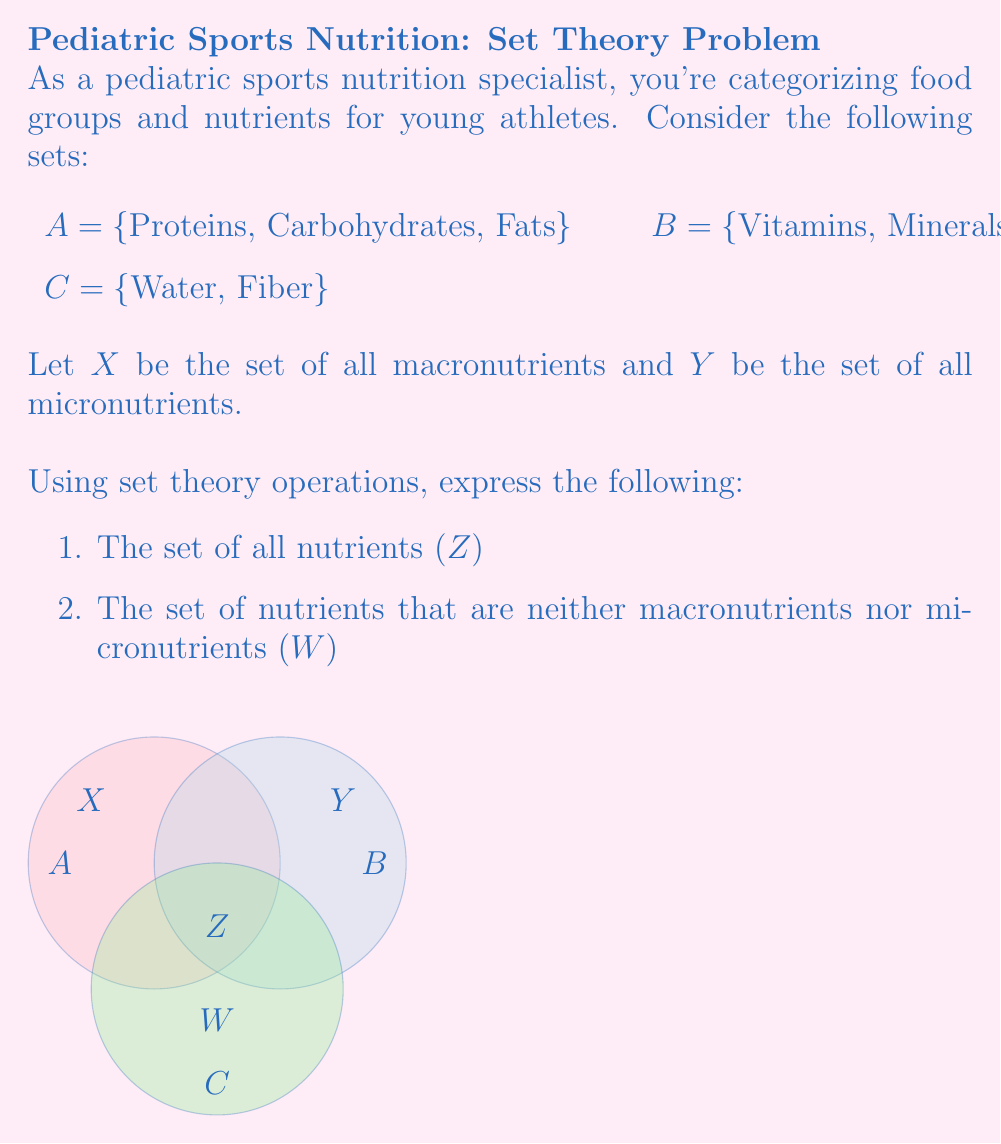Teach me how to tackle this problem. Let's approach this step-by-step:

1. To find the set of all nutrients (Z):
   - We need to combine all the given sets using the union operation.
   - Z = A ∪ B ∪ C

2. To find the set of nutrients that are neither macronutrients nor micronutrients (W):
   - First, we need to define X and Y:
     X = A (macronutrients are proteins, carbohydrates, and fats)
     Y = B (micronutrients are vitamins and minerals)
   - W is the set of elements in Z that are not in X or Y
   - We can express this using set difference:
     W = Z - (X ∪ Y)

Using set theory notation:

$$Z = A \cup B \cup C$$
$$W = (A \cup B \cup C) - (A \cup B)$$

Simplifying W:
$$W = C - (A \cup B)$$

Since C is disjoint from both A and B, we can conclude:
$$W = C = \{Water, Fiber\}$$

This makes sense nutritionally, as water and fiber are important components of a diet but are neither macro nor micronutrients in the traditional classification.
Answer: 1. Z = A ∪ B ∪ C
2. W = C = {Water, Fiber} 